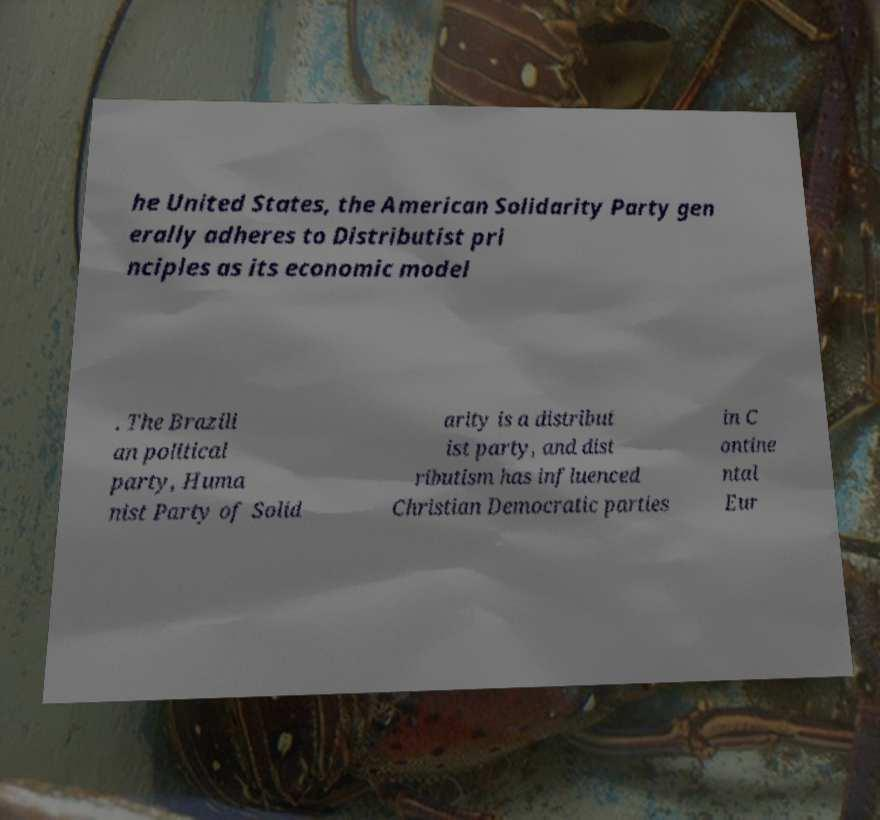What messages or text are displayed in this image? I need them in a readable, typed format. he United States, the American Solidarity Party gen erally adheres to Distributist pri nciples as its economic model . The Brazili an political party, Huma nist Party of Solid arity is a distribut ist party, and dist ributism has influenced Christian Democratic parties in C ontine ntal Eur 